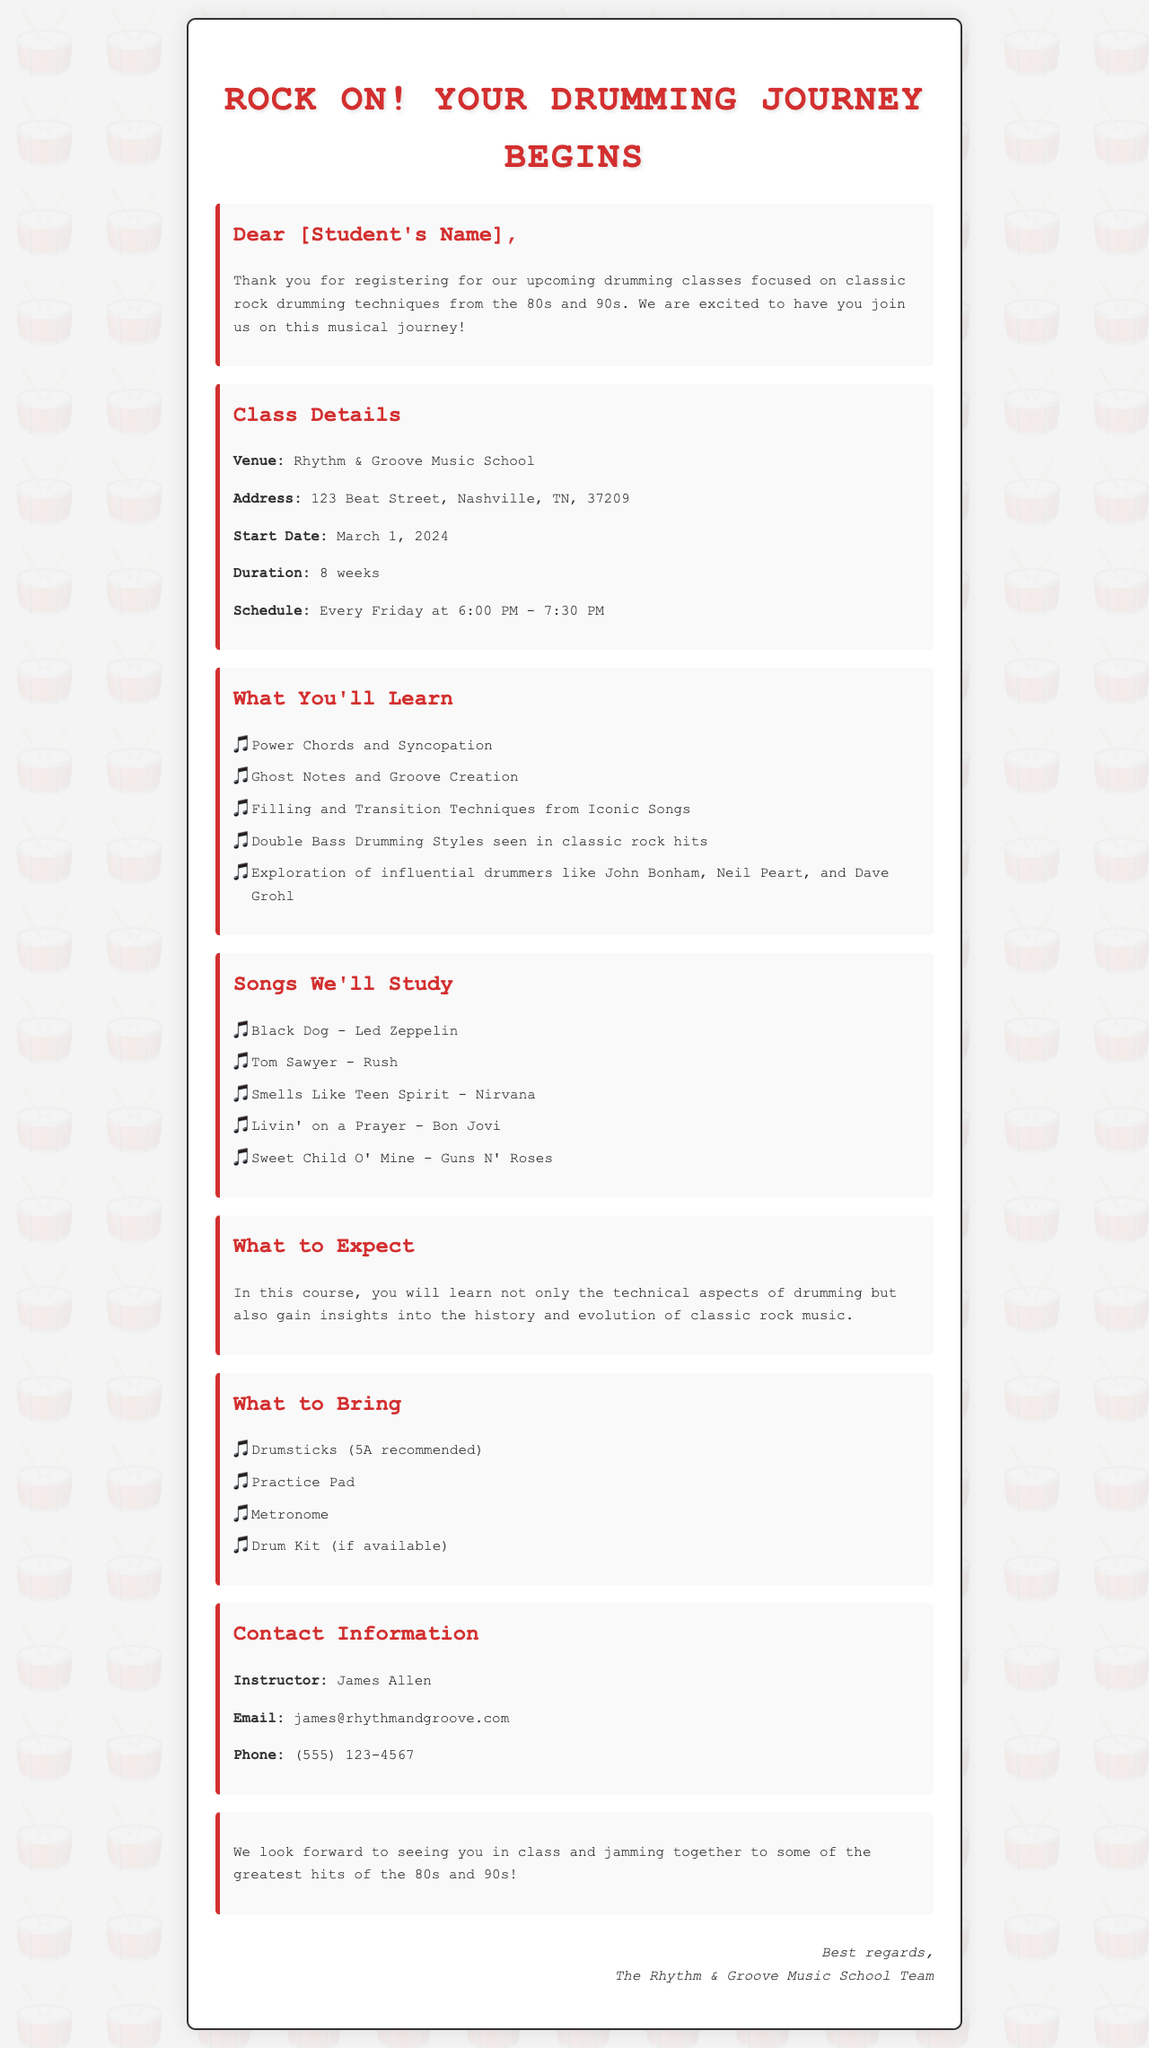what is the name of the music school? The music school where the classes are held is mentioned in the document.
Answer: Rhythm & Groove Music School what is the address of the music school? The document provides the specific location of the school.
Answer: 123 Beat Street, Nashville, TN, 37209 when do the classes start? The start date of the classes is given in the document.
Answer: March 1, 2024 how long is the course duration? The document states the length of the upcoming classes.
Answer: 8 weeks what day of the week are classes held? The schedule indicates which day the classes will take place.
Answer: Every Friday who is the instructor? The document lists the name of the instructor for the classes.
Answer: James Allen which iconic song by Nirvana will be studied? The document includes a specific song from a well-known band featured in the course.
Answer: Smells Like Teen Spirit what type of drumsticks are recommended? The document specifies the type of drumsticks that should be brought to class.
Answer: 5A recommended what should students bring to class? The document outlines essential items that participants need for the lessons.
Answer: Drumsticks, Practice Pad, Metronome, Drum Kit (if available) 